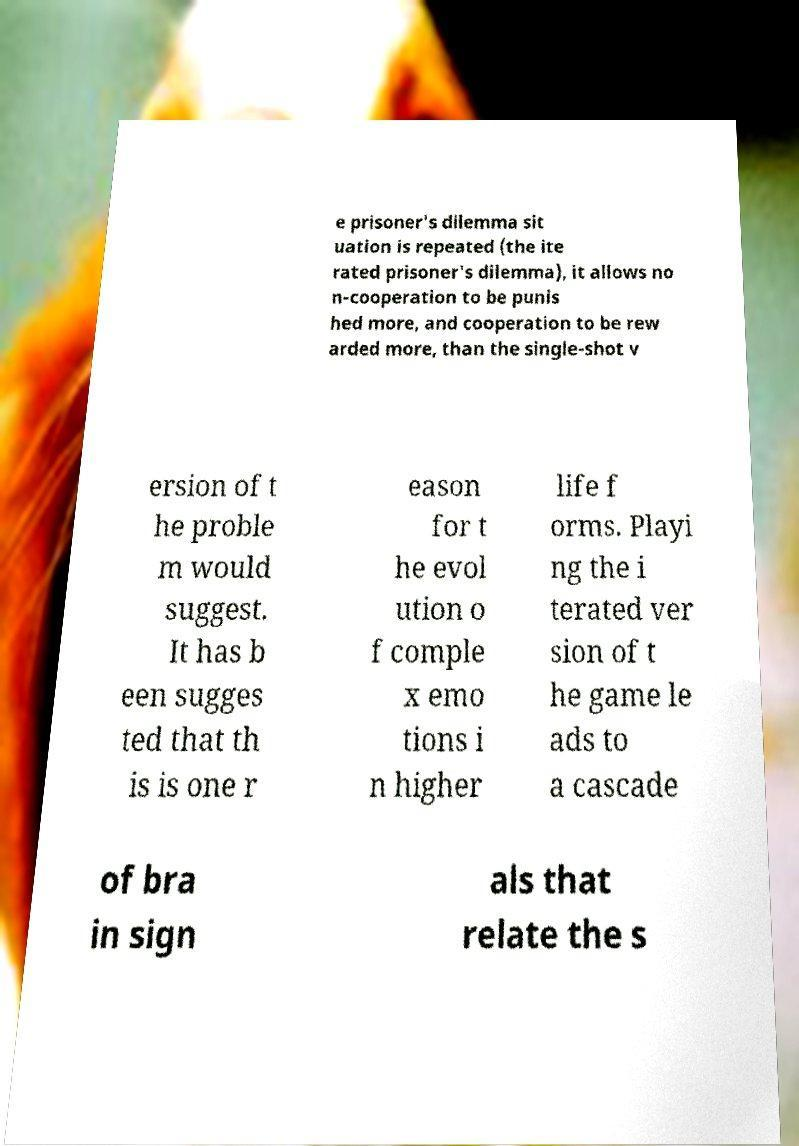Can you accurately transcribe the text from the provided image for me? e prisoner's dilemma sit uation is repeated (the ite rated prisoner's dilemma), it allows no n-cooperation to be punis hed more, and cooperation to be rew arded more, than the single-shot v ersion of t he proble m would suggest. It has b een sugges ted that th is is one r eason for t he evol ution o f comple x emo tions i n higher life f orms. Playi ng the i terated ver sion of t he game le ads to a cascade of bra in sign als that relate the s 